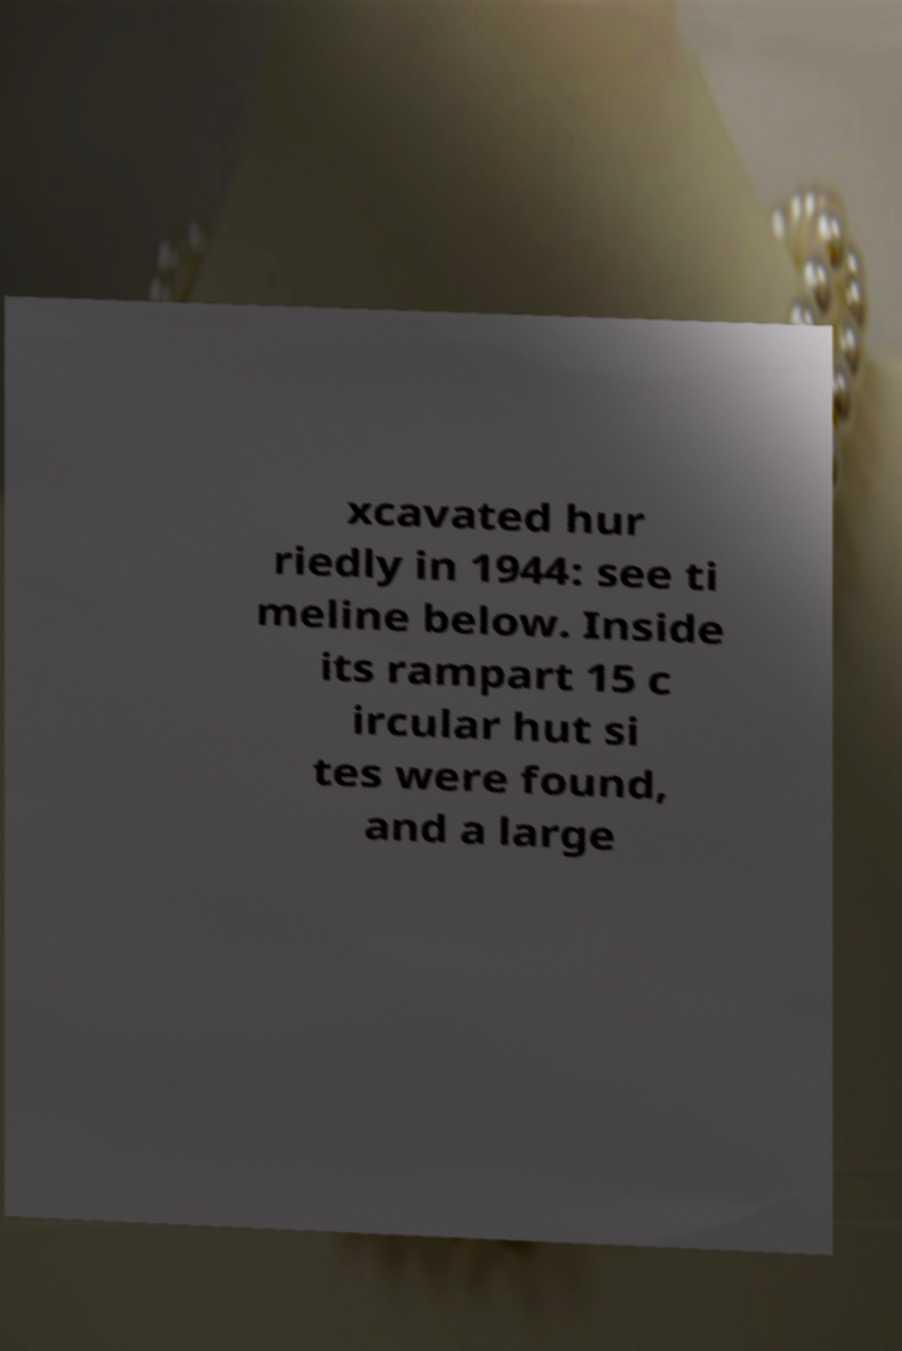I need the written content from this picture converted into text. Can you do that? xcavated hur riedly in 1944: see ti meline below. Inside its rampart 15 c ircular hut si tes were found, and a large 